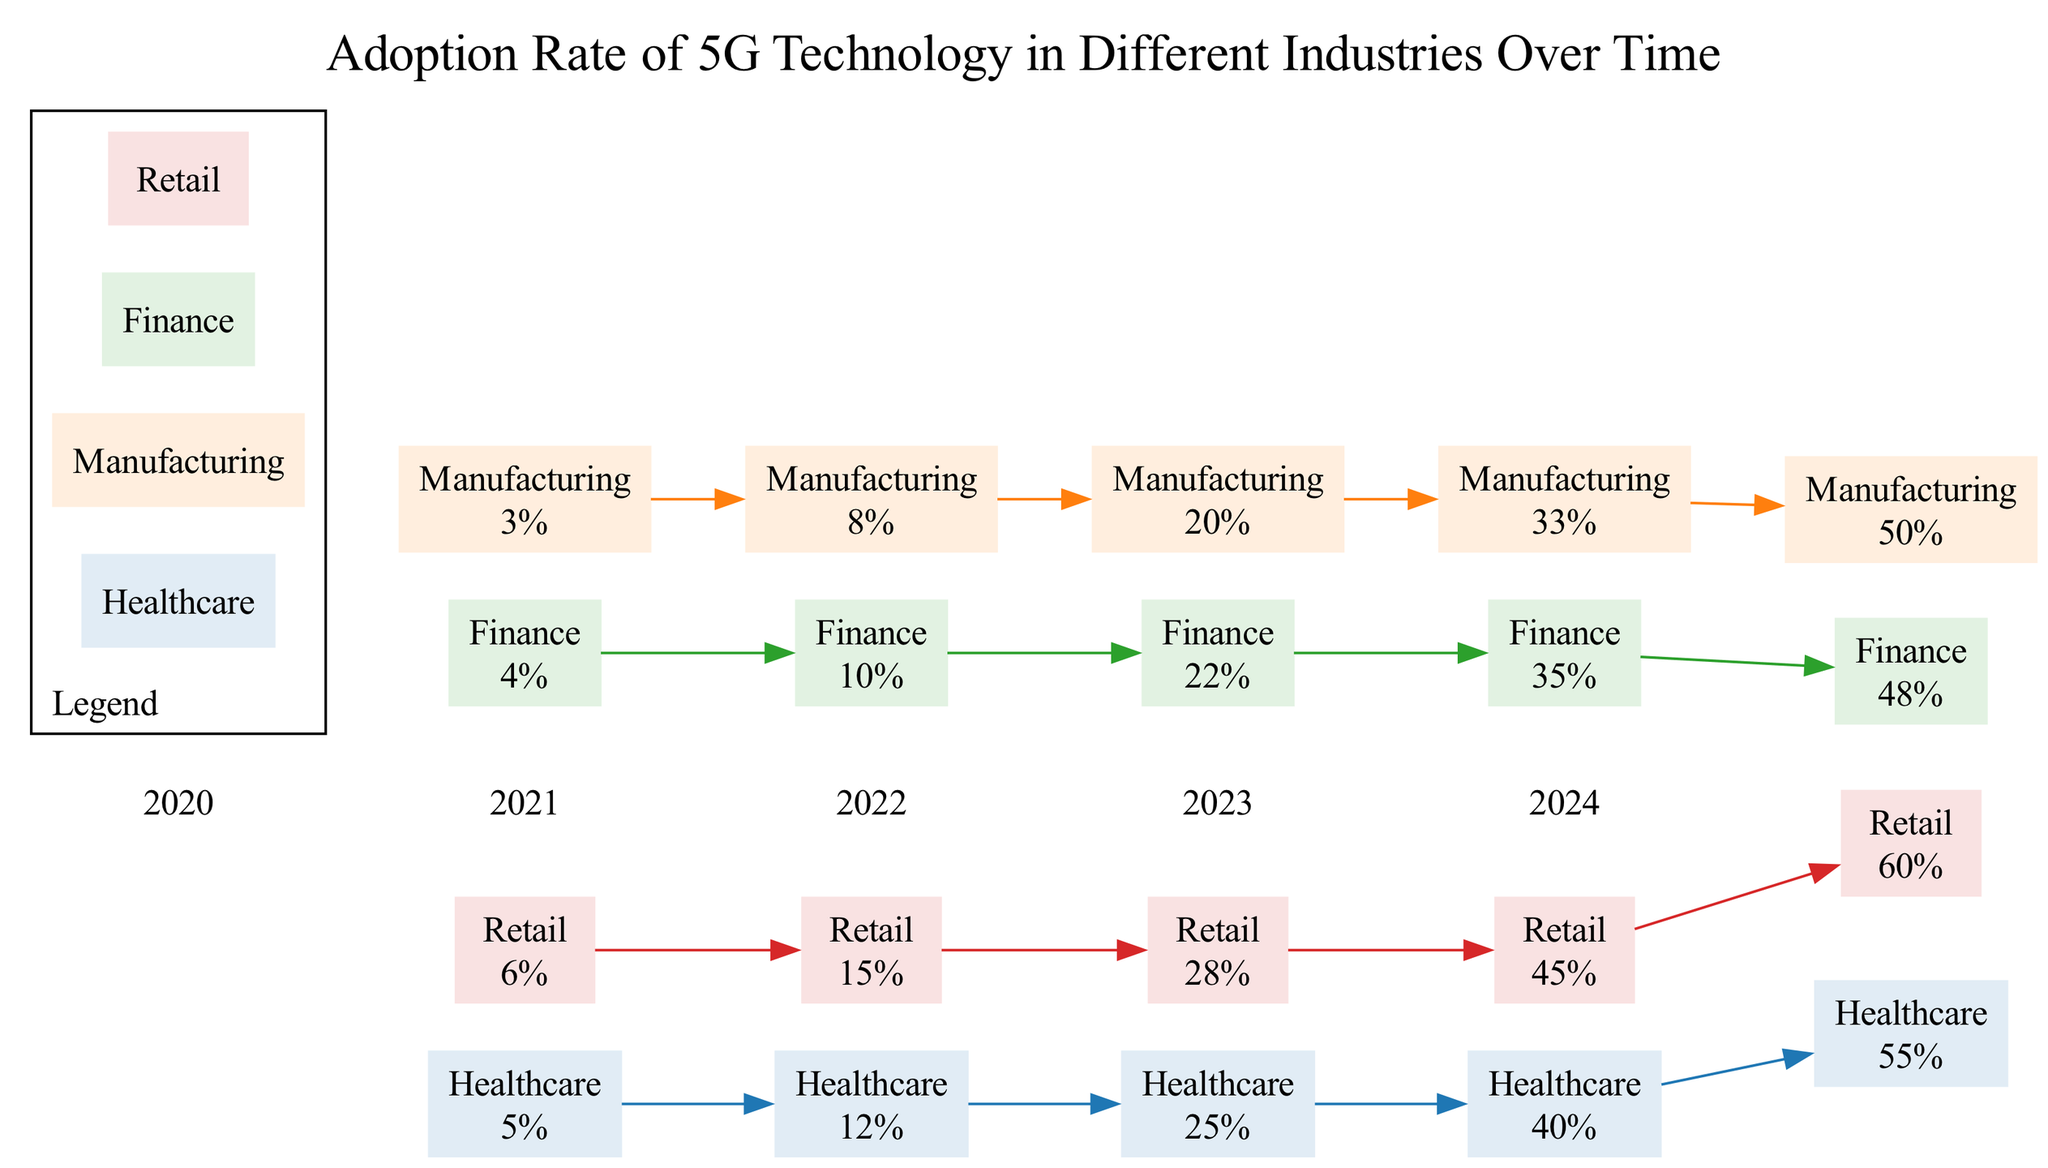What is the adoption rate of 5G technology in the healthcare industry in 2024? The diagram displays the adoption rates for the healthcare industry over the years. In the year 2024, the healthcare adoption rate is specifically noted as 55%.
Answer: 55% Which industry shows the highest adoption rate in 2023? By examining the adoption rates for each industry in 2023, we see that the retail industry has the highest rate at 45%, compared to healthcare (40%), manufacturing (33%), and finance (35%).
Answer: Retail How many industries are represented in the diagram? The diagram includes four lines, each representing a different industry: healthcare, manufacturing, finance, and retail. Thus, there are four distinct industries.
Answer: Four What was the growth in adoption rate for the manufacturing industry from 2022 to 2024? To find the growth between 2022 and 2024, we compare the adoption rates: in 2022 it was 20% and in 2024 it is 50%. The growth is calculated as 50% - 20%, which equals 30%.
Answer: 30% Which industry's adoption rate increased by the smallest amount from 2023 to 2024? Checking the adoption rates from 2023 to 2024, healthcare increased from 40% to 55%, manufacturing from 33% to 50%, finance from 35% to 48%, and retail from 45% to 60%. The smallest increase is in finance, which is 48% - 35% = 13%.
Answer: Finance What was the adoption rate of 5G in finance in 2020? The diagram indicates the adoption rate of finance in 2020 as 4%. This is directly stated in the industry’s data points for that year.
Answer: 4% What color represents the healthcare industry in the diagram? Each industry is assigned a specific color in the diagram. The healthcare industry corresponds to the first color identified in the defined color palette, which is #1f77b4 (blue).
Answer: Blue In what year did the retail industry first exceed a 40% adoption rate? Looking at the data points for the retail industry, the adoption rate first surpasses 40% in 2023. In 2022, it was still below that threshold at 28%.
Answer: 2023 What is the trend of adoption rates for healthcare from 2020 to 2024? Analyzing the healthcare data points, the adoption rate shows a consistent upward trend, starting at 5% in 2020 and reaching 55% in 2024, reflecting significant growth over the years.
Answer: Increasing 